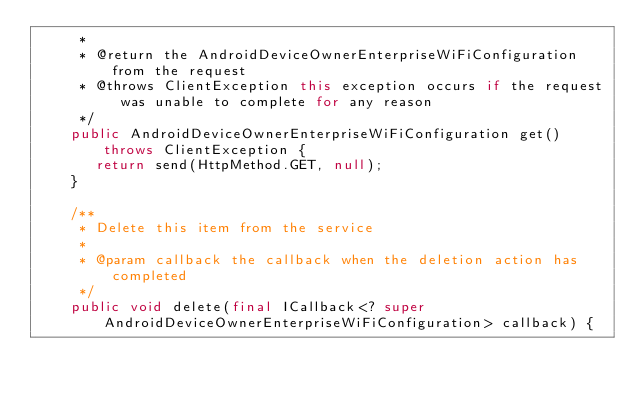<code> <loc_0><loc_0><loc_500><loc_500><_Java_>     *
     * @return the AndroidDeviceOwnerEnterpriseWiFiConfiguration from the request
     * @throws ClientException this exception occurs if the request was unable to complete for any reason
     */
    public AndroidDeviceOwnerEnterpriseWiFiConfiguration get() throws ClientException {
       return send(HttpMethod.GET, null);
    }

    /**
     * Delete this item from the service
     *
     * @param callback the callback when the deletion action has completed
     */
    public void delete(final ICallback<? super AndroidDeviceOwnerEnterpriseWiFiConfiguration> callback) {</code> 